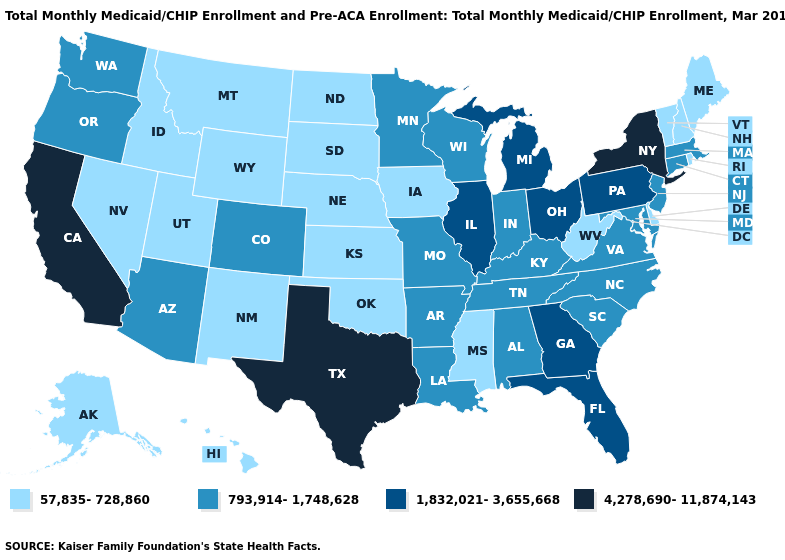Does Texas have the highest value in the USA?
Short answer required. Yes. Does the map have missing data?
Keep it brief. No. What is the value of Rhode Island?
Give a very brief answer. 57,835-728,860. How many symbols are there in the legend?
Give a very brief answer. 4. What is the highest value in the Northeast ?
Keep it brief. 4,278,690-11,874,143. Does Texas have the highest value in the South?
Concise answer only. Yes. Name the states that have a value in the range 4,278,690-11,874,143?
Write a very short answer. California, New York, Texas. How many symbols are there in the legend?
Give a very brief answer. 4. Name the states that have a value in the range 57,835-728,860?
Write a very short answer. Alaska, Delaware, Hawaii, Idaho, Iowa, Kansas, Maine, Mississippi, Montana, Nebraska, Nevada, New Hampshire, New Mexico, North Dakota, Oklahoma, Rhode Island, South Dakota, Utah, Vermont, West Virginia, Wyoming. Which states have the lowest value in the MidWest?
Answer briefly. Iowa, Kansas, Nebraska, North Dakota, South Dakota. What is the highest value in the USA?
Short answer required. 4,278,690-11,874,143. Name the states that have a value in the range 793,914-1,748,628?
Be succinct. Alabama, Arizona, Arkansas, Colorado, Connecticut, Indiana, Kentucky, Louisiana, Maryland, Massachusetts, Minnesota, Missouri, New Jersey, North Carolina, Oregon, South Carolina, Tennessee, Virginia, Washington, Wisconsin. What is the value of Alabama?
Keep it brief. 793,914-1,748,628. What is the value of North Carolina?
Write a very short answer. 793,914-1,748,628. Does Florida have a higher value than Texas?
Answer briefly. No. 